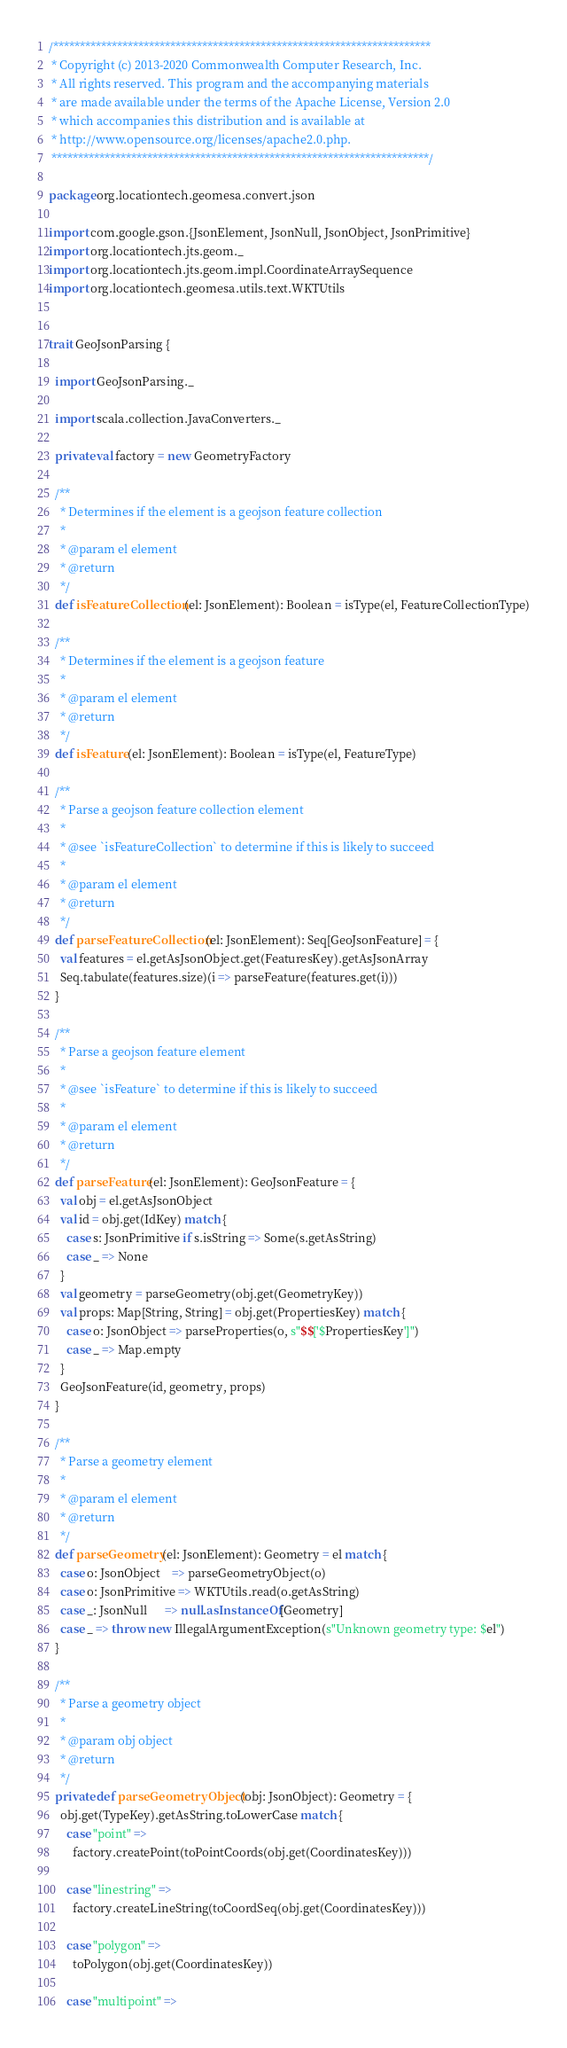<code> <loc_0><loc_0><loc_500><loc_500><_Scala_>/***********************************************************************
 * Copyright (c) 2013-2020 Commonwealth Computer Research, Inc.
 * All rights reserved. This program and the accompanying materials
 * are made available under the terms of the Apache License, Version 2.0
 * which accompanies this distribution and is available at
 * http://www.opensource.org/licenses/apache2.0.php.
 ***********************************************************************/

package org.locationtech.geomesa.convert.json

import com.google.gson.{JsonElement, JsonNull, JsonObject, JsonPrimitive}
import org.locationtech.jts.geom._
import org.locationtech.jts.geom.impl.CoordinateArraySequence
import org.locationtech.geomesa.utils.text.WKTUtils


trait GeoJsonParsing {

  import GeoJsonParsing._

  import scala.collection.JavaConverters._

  private val factory = new GeometryFactory

  /**
    * Determines if the element is a geojson feature collection
    *
    * @param el element
    * @return
    */
  def isFeatureCollection(el: JsonElement): Boolean = isType(el, FeatureCollectionType)

  /**
    * Determines if the element is a geojson feature
    *
    * @param el element
    * @return
    */
  def isFeature(el: JsonElement): Boolean = isType(el, FeatureType)

  /**
    * Parse a geojson feature collection element
    *
    * @see `isFeatureCollection` to determine if this is likely to succeed
    *
    * @param el element
    * @return
    */
  def parseFeatureCollection(el: JsonElement): Seq[GeoJsonFeature] = {
    val features = el.getAsJsonObject.get(FeaturesKey).getAsJsonArray
    Seq.tabulate(features.size)(i => parseFeature(features.get(i)))
  }

  /**
    * Parse a geojson feature element
    *
    * @see `isFeature` to determine if this is likely to succeed
    *
    * @param el element
    * @return
    */
  def parseFeature(el: JsonElement): GeoJsonFeature = {
    val obj = el.getAsJsonObject
    val id = obj.get(IdKey) match {
      case s: JsonPrimitive if s.isString => Some(s.getAsString)
      case _ => None
    }
    val geometry = parseGeometry(obj.get(GeometryKey))
    val props: Map[String, String] = obj.get(PropertiesKey) match {
      case o: JsonObject => parseProperties(o, s"$$['$PropertiesKey']")
      case _ => Map.empty
    }
    GeoJsonFeature(id, geometry, props)
  }

  /**
    * Parse a geometry element
    *
    * @param el element
    * @return
    */
  def parseGeometry(el: JsonElement): Geometry = el match {
    case o: JsonObject    => parseGeometryObject(o)
    case o: JsonPrimitive => WKTUtils.read(o.getAsString)
    case _: JsonNull      => null.asInstanceOf[Geometry]
    case _ => throw new IllegalArgumentException(s"Unknown geometry type: $el")
  }

  /**
    * Parse a geometry object
    *
    * @param obj object
    * @return
    */
  private def parseGeometryObject(obj: JsonObject): Geometry = {
    obj.get(TypeKey).getAsString.toLowerCase match {
      case "point" =>
        factory.createPoint(toPointCoords(obj.get(CoordinatesKey)))

      case "linestring" =>
        factory.createLineString(toCoordSeq(obj.get(CoordinatesKey)))

      case "polygon" =>
        toPolygon(obj.get(CoordinatesKey))

      case "multipoint" =></code> 